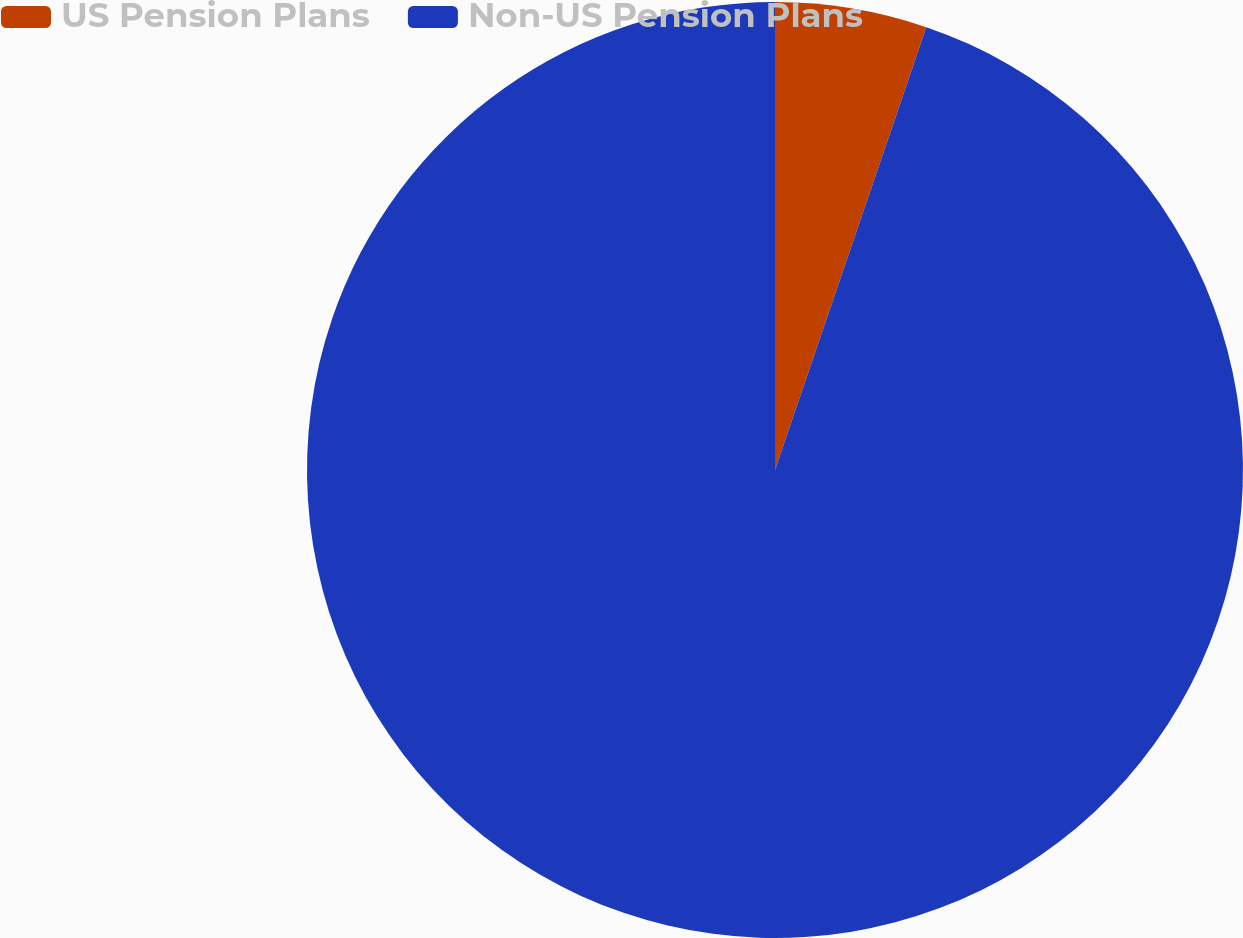<chart> <loc_0><loc_0><loc_500><loc_500><pie_chart><fcel>US Pension Plans<fcel>Non-US Pension Plans<nl><fcel>5.24%<fcel>94.76%<nl></chart> 